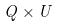Convert formula to latex. <formula><loc_0><loc_0><loc_500><loc_500>Q \times U</formula> 